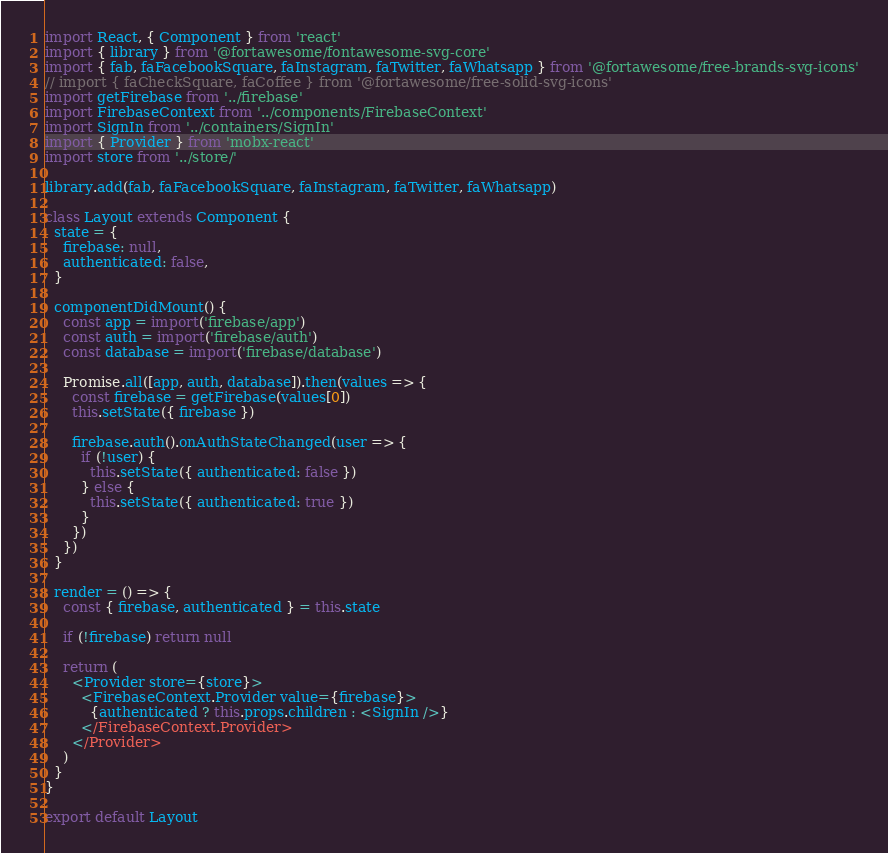<code> <loc_0><loc_0><loc_500><loc_500><_JavaScript_>import React, { Component } from 'react'
import { library } from '@fortawesome/fontawesome-svg-core'
import { fab, faFacebookSquare, faInstagram, faTwitter, faWhatsapp } from '@fortawesome/free-brands-svg-icons'
// import { faCheckSquare, faCoffee } from '@fortawesome/free-solid-svg-icons'
import getFirebase from '../firebase'
import FirebaseContext from '../components/FirebaseContext'
import SignIn from '../containers/SignIn'
import { Provider } from 'mobx-react'
import store from '../store/'

library.add(fab, faFacebookSquare, faInstagram, faTwitter, faWhatsapp)

class Layout extends Component {
  state = {
    firebase: null,
    authenticated: false,
  }

  componentDidMount() {
    const app = import('firebase/app')
    const auth = import('firebase/auth')
    const database = import('firebase/database')

    Promise.all([app, auth, database]).then(values => {
      const firebase = getFirebase(values[0])
      this.setState({ firebase })

      firebase.auth().onAuthStateChanged(user => {
        if (!user) {
          this.setState({ authenticated: false })
        } else {
          this.setState({ authenticated: true })
        }
      })
    })
  }

  render = () => {
    const { firebase, authenticated } = this.state

    if (!firebase) return null

    return (
      <Provider store={store}>
        <FirebaseContext.Provider value={firebase}>
          {authenticated ? this.props.children : <SignIn />}
        </FirebaseContext.Provider>
      </Provider>
    )
  }
}

export default Layout
</code> 